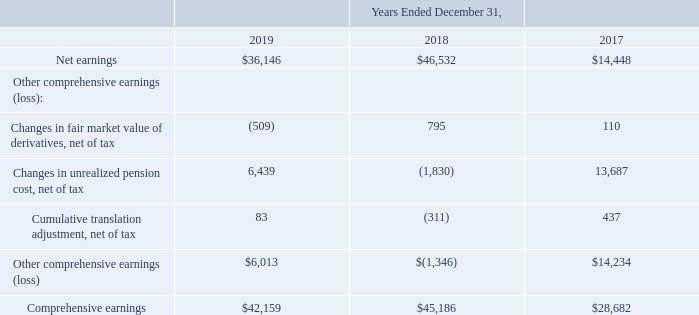CTS CORPORATION AND SUBSIDIARIES Consolidated Statements of Comprehensive Earnings (in thousands)
The accompanying notes are an integral part of the consolidated financial statements.
Which years does the table provide information for the company's Consolidated Statements of Comprehensive Earnings? 2019, 2018, 2017. What were the net earnings in 2019?
Answer scale should be: thousand. 36,146. What was the Changes in fair market value of derivatives, net of tax in 2018?
Answer scale should be: thousand. 795. How many years did net earnings exceed $30,000 thousand? 2019##2018
Answer: 2. What was the change in the Other comprehensive earnings  between 2017 and 2019?
Answer scale should be: thousand. 6,013-14,234
Answer: -8221. What was the percentage change in Comprehensive earnings between 2017 and 2018?
Answer scale should be: percent. (45,186-28,682)/28,682
Answer: 57.54. 